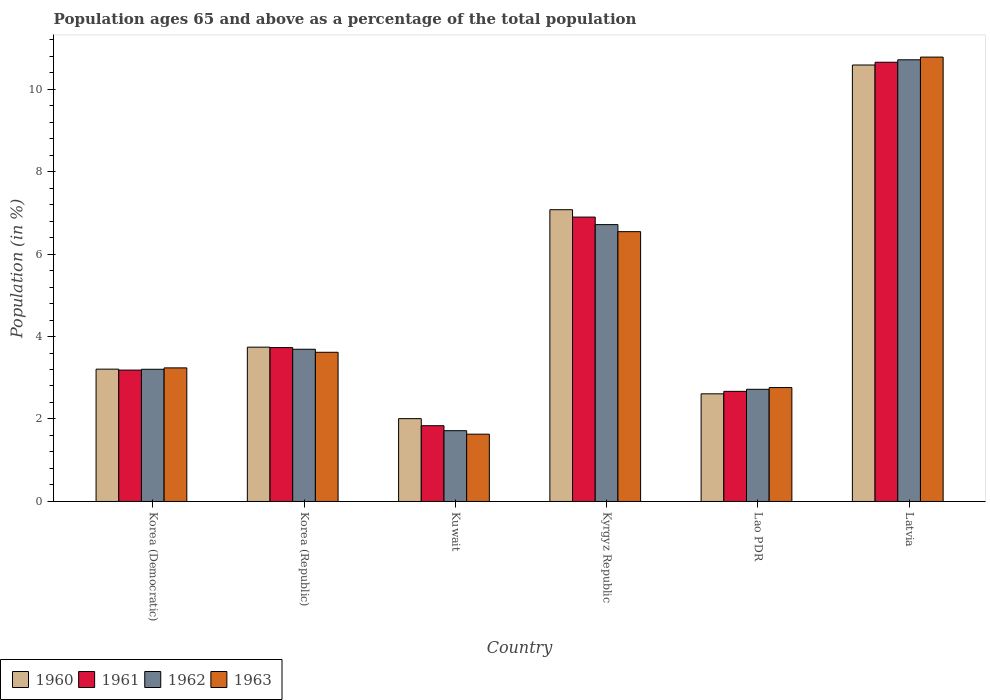How many different coloured bars are there?
Provide a short and direct response. 4. Are the number of bars per tick equal to the number of legend labels?
Offer a very short reply. Yes. How many bars are there on the 6th tick from the left?
Your answer should be compact. 4. How many bars are there on the 4th tick from the right?
Give a very brief answer. 4. In how many cases, is the number of bars for a given country not equal to the number of legend labels?
Keep it short and to the point. 0. What is the percentage of the population ages 65 and above in 1960 in Latvia?
Give a very brief answer. 10.58. Across all countries, what is the maximum percentage of the population ages 65 and above in 1960?
Give a very brief answer. 10.58. Across all countries, what is the minimum percentage of the population ages 65 and above in 1963?
Keep it short and to the point. 1.63. In which country was the percentage of the population ages 65 and above in 1962 maximum?
Provide a short and direct response. Latvia. In which country was the percentage of the population ages 65 and above in 1963 minimum?
Provide a succinct answer. Kuwait. What is the total percentage of the population ages 65 and above in 1962 in the graph?
Give a very brief answer. 28.75. What is the difference between the percentage of the population ages 65 and above in 1963 in Korea (Democratic) and that in Kyrgyz Republic?
Offer a very short reply. -3.3. What is the difference between the percentage of the population ages 65 and above in 1963 in Korea (Republic) and the percentage of the population ages 65 and above in 1961 in Lao PDR?
Provide a succinct answer. 0.95. What is the average percentage of the population ages 65 and above in 1960 per country?
Provide a succinct answer. 4.87. What is the difference between the percentage of the population ages 65 and above of/in 1963 and percentage of the population ages 65 and above of/in 1961 in Lao PDR?
Your answer should be compact. 0.09. What is the ratio of the percentage of the population ages 65 and above in 1960 in Korea (Democratic) to that in Lao PDR?
Provide a short and direct response. 1.23. Is the difference between the percentage of the population ages 65 and above in 1963 in Kyrgyz Republic and Latvia greater than the difference between the percentage of the population ages 65 and above in 1961 in Kyrgyz Republic and Latvia?
Provide a short and direct response. No. What is the difference between the highest and the second highest percentage of the population ages 65 and above in 1962?
Provide a short and direct response. 7.02. What is the difference between the highest and the lowest percentage of the population ages 65 and above in 1960?
Give a very brief answer. 8.57. In how many countries, is the percentage of the population ages 65 and above in 1961 greater than the average percentage of the population ages 65 and above in 1961 taken over all countries?
Your answer should be compact. 2. Is it the case that in every country, the sum of the percentage of the population ages 65 and above in 1961 and percentage of the population ages 65 and above in 1963 is greater than the sum of percentage of the population ages 65 and above in 1960 and percentage of the population ages 65 and above in 1962?
Offer a very short reply. No. How many bars are there?
Your response must be concise. 24. How many countries are there in the graph?
Your answer should be very brief. 6. What is the difference between two consecutive major ticks on the Y-axis?
Provide a short and direct response. 2. Are the values on the major ticks of Y-axis written in scientific E-notation?
Offer a very short reply. No. Does the graph contain grids?
Your answer should be compact. No. What is the title of the graph?
Make the answer very short. Population ages 65 and above as a percentage of the total population. Does "1963" appear as one of the legend labels in the graph?
Keep it short and to the point. Yes. What is the label or title of the X-axis?
Give a very brief answer. Country. What is the Population (in %) of 1960 in Korea (Democratic)?
Your answer should be very brief. 3.21. What is the Population (in %) of 1961 in Korea (Democratic)?
Ensure brevity in your answer.  3.19. What is the Population (in %) in 1962 in Korea (Democratic)?
Your answer should be compact. 3.21. What is the Population (in %) of 1963 in Korea (Democratic)?
Offer a terse response. 3.24. What is the Population (in %) of 1960 in Korea (Republic)?
Provide a short and direct response. 3.74. What is the Population (in %) of 1961 in Korea (Republic)?
Ensure brevity in your answer.  3.73. What is the Population (in %) in 1962 in Korea (Republic)?
Your answer should be very brief. 3.69. What is the Population (in %) of 1963 in Korea (Republic)?
Provide a succinct answer. 3.62. What is the Population (in %) of 1960 in Kuwait?
Make the answer very short. 2.01. What is the Population (in %) of 1961 in Kuwait?
Make the answer very short. 1.84. What is the Population (in %) in 1962 in Kuwait?
Give a very brief answer. 1.72. What is the Population (in %) in 1963 in Kuwait?
Keep it short and to the point. 1.63. What is the Population (in %) in 1960 in Kyrgyz Republic?
Provide a short and direct response. 7.07. What is the Population (in %) of 1961 in Kyrgyz Republic?
Give a very brief answer. 6.9. What is the Population (in %) of 1962 in Kyrgyz Republic?
Offer a very short reply. 6.71. What is the Population (in %) in 1963 in Kyrgyz Republic?
Your answer should be very brief. 6.54. What is the Population (in %) of 1960 in Lao PDR?
Provide a succinct answer. 2.61. What is the Population (in %) in 1961 in Lao PDR?
Keep it short and to the point. 2.67. What is the Population (in %) in 1962 in Lao PDR?
Provide a succinct answer. 2.72. What is the Population (in %) in 1963 in Lao PDR?
Keep it short and to the point. 2.76. What is the Population (in %) in 1960 in Latvia?
Provide a succinct answer. 10.58. What is the Population (in %) in 1961 in Latvia?
Provide a short and direct response. 10.65. What is the Population (in %) of 1962 in Latvia?
Provide a succinct answer. 10.71. What is the Population (in %) of 1963 in Latvia?
Offer a terse response. 10.77. Across all countries, what is the maximum Population (in %) in 1960?
Offer a very short reply. 10.58. Across all countries, what is the maximum Population (in %) in 1961?
Your response must be concise. 10.65. Across all countries, what is the maximum Population (in %) of 1962?
Provide a succinct answer. 10.71. Across all countries, what is the maximum Population (in %) of 1963?
Your answer should be very brief. 10.77. Across all countries, what is the minimum Population (in %) in 1960?
Make the answer very short. 2.01. Across all countries, what is the minimum Population (in %) in 1961?
Your response must be concise. 1.84. Across all countries, what is the minimum Population (in %) in 1962?
Offer a terse response. 1.72. Across all countries, what is the minimum Population (in %) of 1963?
Your answer should be very brief. 1.63. What is the total Population (in %) in 1960 in the graph?
Keep it short and to the point. 29.23. What is the total Population (in %) in 1961 in the graph?
Your answer should be very brief. 28.97. What is the total Population (in %) in 1962 in the graph?
Offer a terse response. 28.75. What is the total Population (in %) of 1963 in the graph?
Make the answer very short. 28.57. What is the difference between the Population (in %) of 1960 in Korea (Democratic) and that in Korea (Republic)?
Offer a terse response. -0.53. What is the difference between the Population (in %) in 1961 in Korea (Democratic) and that in Korea (Republic)?
Offer a terse response. -0.55. What is the difference between the Population (in %) of 1962 in Korea (Democratic) and that in Korea (Republic)?
Offer a very short reply. -0.49. What is the difference between the Population (in %) of 1963 in Korea (Democratic) and that in Korea (Republic)?
Offer a terse response. -0.38. What is the difference between the Population (in %) in 1960 in Korea (Democratic) and that in Kuwait?
Provide a short and direct response. 1.2. What is the difference between the Population (in %) in 1961 in Korea (Democratic) and that in Kuwait?
Provide a succinct answer. 1.35. What is the difference between the Population (in %) in 1962 in Korea (Democratic) and that in Kuwait?
Ensure brevity in your answer.  1.49. What is the difference between the Population (in %) in 1963 in Korea (Democratic) and that in Kuwait?
Offer a terse response. 1.61. What is the difference between the Population (in %) in 1960 in Korea (Democratic) and that in Kyrgyz Republic?
Your answer should be very brief. -3.87. What is the difference between the Population (in %) of 1961 in Korea (Democratic) and that in Kyrgyz Republic?
Ensure brevity in your answer.  -3.71. What is the difference between the Population (in %) in 1962 in Korea (Democratic) and that in Kyrgyz Republic?
Keep it short and to the point. -3.51. What is the difference between the Population (in %) in 1963 in Korea (Democratic) and that in Kyrgyz Republic?
Provide a short and direct response. -3.3. What is the difference between the Population (in %) in 1960 in Korea (Democratic) and that in Lao PDR?
Offer a very short reply. 0.6. What is the difference between the Population (in %) in 1961 in Korea (Democratic) and that in Lao PDR?
Your answer should be very brief. 0.52. What is the difference between the Population (in %) of 1962 in Korea (Democratic) and that in Lao PDR?
Your answer should be very brief. 0.49. What is the difference between the Population (in %) in 1963 in Korea (Democratic) and that in Lao PDR?
Make the answer very short. 0.48. What is the difference between the Population (in %) of 1960 in Korea (Democratic) and that in Latvia?
Give a very brief answer. -7.37. What is the difference between the Population (in %) in 1961 in Korea (Democratic) and that in Latvia?
Keep it short and to the point. -7.46. What is the difference between the Population (in %) of 1962 in Korea (Democratic) and that in Latvia?
Your response must be concise. -7.5. What is the difference between the Population (in %) in 1963 in Korea (Democratic) and that in Latvia?
Your answer should be very brief. -7.54. What is the difference between the Population (in %) of 1960 in Korea (Republic) and that in Kuwait?
Give a very brief answer. 1.73. What is the difference between the Population (in %) in 1961 in Korea (Republic) and that in Kuwait?
Offer a terse response. 1.89. What is the difference between the Population (in %) of 1962 in Korea (Republic) and that in Kuwait?
Provide a succinct answer. 1.97. What is the difference between the Population (in %) of 1963 in Korea (Republic) and that in Kuwait?
Your response must be concise. 1.99. What is the difference between the Population (in %) of 1960 in Korea (Republic) and that in Kyrgyz Republic?
Offer a very short reply. -3.33. What is the difference between the Population (in %) in 1961 in Korea (Republic) and that in Kyrgyz Republic?
Provide a short and direct response. -3.16. What is the difference between the Population (in %) in 1962 in Korea (Republic) and that in Kyrgyz Republic?
Your response must be concise. -3.02. What is the difference between the Population (in %) in 1963 in Korea (Republic) and that in Kyrgyz Republic?
Your answer should be very brief. -2.93. What is the difference between the Population (in %) of 1960 in Korea (Republic) and that in Lao PDR?
Ensure brevity in your answer.  1.13. What is the difference between the Population (in %) of 1961 in Korea (Republic) and that in Lao PDR?
Provide a short and direct response. 1.06. What is the difference between the Population (in %) in 1962 in Korea (Republic) and that in Lao PDR?
Make the answer very short. 0.97. What is the difference between the Population (in %) in 1963 in Korea (Republic) and that in Lao PDR?
Your answer should be very brief. 0.86. What is the difference between the Population (in %) of 1960 in Korea (Republic) and that in Latvia?
Offer a terse response. -6.84. What is the difference between the Population (in %) of 1961 in Korea (Republic) and that in Latvia?
Keep it short and to the point. -6.92. What is the difference between the Population (in %) of 1962 in Korea (Republic) and that in Latvia?
Your response must be concise. -7.02. What is the difference between the Population (in %) of 1963 in Korea (Republic) and that in Latvia?
Your answer should be very brief. -7.16. What is the difference between the Population (in %) in 1960 in Kuwait and that in Kyrgyz Republic?
Your answer should be compact. -5.07. What is the difference between the Population (in %) in 1961 in Kuwait and that in Kyrgyz Republic?
Make the answer very short. -5.06. What is the difference between the Population (in %) in 1962 in Kuwait and that in Kyrgyz Republic?
Give a very brief answer. -5. What is the difference between the Population (in %) in 1963 in Kuwait and that in Kyrgyz Republic?
Keep it short and to the point. -4.91. What is the difference between the Population (in %) of 1960 in Kuwait and that in Lao PDR?
Give a very brief answer. -0.6. What is the difference between the Population (in %) in 1961 in Kuwait and that in Lao PDR?
Ensure brevity in your answer.  -0.83. What is the difference between the Population (in %) of 1962 in Kuwait and that in Lao PDR?
Your response must be concise. -1. What is the difference between the Population (in %) in 1963 in Kuwait and that in Lao PDR?
Offer a very short reply. -1.13. What is the difference between the Population (in %) in 1960 in Kuwait and that in Latvia?
Your response must be concise. -8.57. What is the difference between the Population (in %) in 1961 in Kuwait and that in Latvia?
Provide a short and direct response. -8.81. What is the difference between the Population (in %) of 1962 in Kuwait and that in Latvia?
Provide a short and direct response. -8.99. What is the difference between the Population (in %) in 1963 in Kuwait and that in Latvia?
Your answer should be very brief. -9.14. What is the difference between the Population (in %) in 1960 in Kyrgyz Republic and that in Lao PDR?
Your answer should be compact. 4.46. What is the difference between the Population (in %) in 1961 in Kyrgyz Republic and that in Lao PDR?
Provide a short and direct response. 4.22. What is the difference between the Population (in %) in 1962 in Kyrgyz Republic and that in Lao PDR?
Your answer should be very brief. 3.99. What is the difference between the Population (in %) of 1963 in Kyrgyz Republic and that in Lao PDR?
Provide a short and direct response. 3.78. What is the difference between the Population (in %) in 1960 in Kyrgyz Republic and that in Latvia?
Your response must be concise. -3.51. What is the difference between the Population (in %) in 1961 in Kyrgyz Republic and that in Latvia?
Give a very brief answer. -3.75. What is the difference between the Population (in %) in 1962 in Kyrgyz Republic and that in Latvia?
Your answer should be compact. -4. What is the difference between the Population (in %) of 1963 in Kyrgyz Republic and that in Latvia?
Ensure brevity in your answer.  -4.23. What is the difference between the Population (in %) of 1960 in Lao PDR and that in Latvia?
Offer a very short reply. -7.97. What is the difference between the Population (in %) of 1961 in Lao PDR and that in Latvia?
Offer a very short reply. -7.98. What is the difference between the Population (in %) in 1962 in Lao PDR and that in Latvia?
Give a very brief answer. -7.99. What is the difference between the Population (in %) of 1963 in Lao PDR and that in Latvia?
Your response must be concise. -8.01. What is the difference between the Population (in %) in 1960 in Korea (Democratic) and the Population (in %) in 1961 in Korea (Republic)?
Your response must be concise. -0.52. What is the difference between the Population (in %) of 1960 in Korea (Democratic) and the Population (in %) of 1962 in Korea (Republic)?
Ensure brevity in your answer.  -0.48. What is the difference between the Population (in %) of 1960 in Korea (Democratic) and the Population (in %) of 1963 in Korea (Republic)?
Make the answer very short. -0.41. What is the difference between the Population (in %) in 1961 in Korea (Democratic) and the Population (in %) in 1962 in Korea (Republic)?
Ensure brevity in your answer.  -0.51. What is the difference between the Population (in %) in 1961 in Korea (Democratic) and the Population (in %) in 1963 in Korea (Republic)?
Your answer should be compact. -0.43. What is the difference between the Population (in %) in 1962 in Korea (Democratic) and the Population (in %) in 1963 in Korea (Republic)?
Provide a succinct answer. -0.41. What is the difference between the Population (in %) of 1960 in Korea (Democratic) and the Population (in %) of 1961 in Kuwait?
Provide a succinct answer. 1.37. What is the difference between the Population (in %) of 1960 in Korea (Democratic) and the Population (in %) of 1962 in Kuwait?
Give a very brief answer. 1.49. What is the difference between the Population (in %) in 1960 in Korea (Democratic) and the Population (in %) in 1963 in Kuwait?
Keep it short and to the point. 1.58. What is the difference between the Population (in %) of 1961 in Korea (Democratic) and the Population (in %) of 1962 in Kuwait?
Give a very brief answer. 1.47. What is the difference between the Population (in %) in 1961 in Korea (Democratic) and the Population (in %) in 1963 in Kuwait?
Provide a succinct answer. 1.55. What is the difference between the Population (in %) in 1962 in Korea (Democratic) and the Population (in %) in 1963 in Kuwait?
Your response must be concise. 1.57. What is the difference between the Population (in %) in 1960 in Korea (Democratic) and the Population (in %) in 1961 in Kyrgyz Republic?
Offer a terse response. -3.69. What is the difference between the Population (in %) in 1960 in Korea (Democratic) and the Population (in %) in 1962 in Kyrgyz Republic?
Offer a terse response. -3.5. What is the difference between the Population (in %) in 1960 in Korea (Democratic) and the Population (in %) in 1963 in Kyrgyz Republic?
Your response must be concise. -3.33. What is the difference between the Population (in %) in 1961 in Korea (Democratic) and the Population (in %) in 1962 in Kyrgyz Republic?
Make the answer very short. -3.53. What is the difference between the Population (in %) of 1961 in Korea (Democratic) and the Population (in %) of 1963 in Kyrgyz Republic?
Your answer should be compact. -3.36. What is the difference between the Population (in %) in 1962 in Korea (Democratic) and the Population (in %) in 1963 in Kyrgyz Republic?
Keep it short and to the point. -3.34. What is the difference between the Population (in %) in 1960 in Korea (Democratic) and the Population (in %) in 1961 in Lao PDR?
Provide a succinct answer. 0.54. What is the difference between the Population (in %) in 1960 in Korea (Democratic) and the Population (in %) in 1962 in Lao PDR?
Keep it short and to the point. 0.49. What is the difference between the Population (in %) of 1960 in Korea (Democratic) and the Population (in %) of 1963 in Lao PDR?
Give a very brief answer. 0.45. What is the difference between the Population (in %) in 1961 in Korea (Democratic) and the Population (in %) in 1962 in Lao PDR?
Your answer should be compact. 0.47. What is the difference between the Population (in %) of 1961 in Korea (Democratic) and the Population (in %) of 1963 in Lao PDR?
Your response must be concise. 0.42. What is the difference between the Population (in %) of 1962 in Korea (Democratic) and the Population (in %) of 1963 in Lao PDR?
Provide a short and direct response. 0.44. What is the difference between the Population (in %) in 1960 in Korea (Democratic) and the Population (in %) in 1961 in Latvia?
Provide a succinct answer. -7.44. What is the difference between the Population (in %) of 1960 in Korea (Democratic) and the Population (in %) of 1962 in Latvia?
Offer a terse response. -7.5. What is the difference between the Population (in %) in 1960 in Korea (Democratic) and the Population (in %) in 1963 in Latvia?
Provide a succinct answer. -7.57. What is the difference between the Population (in %) of 1961 in Korea (Democratic) and the Population (in %) of 1962 in Latvia?
Provide a short and direct response. -7.52. What is the difference between the Population (in %) of 1961 in Korea (Democratic) and the Population (in %) of 1963 in Latvia?
Keep it short and to the point. -7.59. What is the difference between the Population (in %) of 1962 in Korea (Democratic) and the Population (in %) of 1963 in Latvia?
Provide a succinct answer. -7.57. What is the difference between the Population (in %) of 1960 in Korea (Republic) and the Population (in %) of 1961 in Kuwait?
Ensure brevity in your answer.  1.9. What is the difference between the Population (in %) of 1960 in Korea (Republic) and the Population (in %) of 1962 in Kuwait?
Your answer should be very brief. 2.03. What is the difference between the Population (in %) in 1960 in Korea (Republic) and the Population (in %) in 1963 in Kuwait?
Ensure brevity in your answer.  2.11. What is the difference between the Population (in %) of 1961 in Korea (Republic) and the Population (in %) of 1962 in Kuwait?
Offer a terse response. 2.02. What is the difference between the Population (in %) in 1961 in Korea (Republic) and the Population (in %) in 1963 in Kuwait?
Offer a terse response. 2.1. What is the difference between the Population (in %) in 1962 in Korea (Republic) and the Population (in %) in 1963 in Kuwait?
Make the answer very short. 2.06. What is the difference between the Population (in %) in 1960 in Korea (Republic) and the Population (in %) in 1961 in Kyrgyz Republic?
Your answer should be compact. -3.15. What is the difference between the Population (in %) in 1960 in Korea (Republic) and the Population (in %) in 1962 in Kyrgyz Republic?
Provide a succinct answer. -2.97. What is the difference between the Population (in %) of 1960 in Korea (Republic) and the Population (in %) of 1963 in Kyrgyz Republic?
Keep it short and to the point. -2.8. What is the difference between the Population (in %) of 1961 in Korea (Republic) and the Population (in %) of 1962 in Kyrgyz Republic?
Keep it short and to the point. -2.98. What is the difference between the Population (in %) in 1961 in Korea (Republic) and the Population (in %) in 1963 in Kyrgyz Republic?
Ensure brevity in your answer.  -2.81. What is the difference between the Population (in %) in 1962 in Korea (Republic) and the Population (in %) in 1963 in Kyrgyz Republic?
Give a very brief answer. -2.85. What is the difference between the Population (in %) of 1960 in Korea (Republic) and the Population (in %) of 1961 in Lao PDR?
Keep it short and to the point. 1.07. What is the difference between the Population (in %) in 1960 in Korea (Republic) and the Population (in %) in 1962 in Lao PDR?
Your answer should be very brief. 1.02. What is the difference between the Population (in %) of 1960 in Korea (Republic) and the Population (in %) of 1963 in Lao PDR?
Provide a succinct answer. 0.98. What is the difference between the Population (in %) of 1961 in Korea (Republic) and the Population (in %) of 1962 in Lao PDR?
Your response must be concise. 1.01. What is the difference between the Population (in %) of 1961 in Korea (Republic) and the Population (in %) of 1963 in Lao PDR?
Your answer should be compact. 0.97. What is the difference between the Population (in %) of 1962 in Korea (Republic) and the Population (in %) of 1963 in Lao PDR?
Offer a very short reply. 0.93. What is the difference between the Population (in %) of 1960 in Korea (Republic) and the Population (in %) of 1961 in Latvia?
Provide a short and direct response. -6.91. What is the difference between the Population (in %) of 1960 in Korea (Republic) and the Population (in %) of 1962 in Latvia?
Your answer should be compact. -6.97. What is the difference between the Population (in %) in 1960 in Korea (Republic) and the Population (in %) in 1963 in Latvia?
Make the answer very short. -7.03. What is the difference between the Population (in %) in 1961 in Korea (Republic) and the Population (in %) in 1962 in Latvia?
Your answer should be compact. -6.98. What is the difference between the Population (in %) of 1961 in Korea (Republic) and the Population (in %) of 1963 in Latvia?
Provide a succinct answer. -7.04. What is the difference between the Population (in %) of 1962 in Korea (Republic) and the Population (in %) of 1963 in Latvia?
Your response must be concise. -7.08. What is the difference between the Population (in %) in 1960 in Kuwait and the Population (in %) in 1961 in Kyrgyz Republic?
Offer a very short reply. -4.89. What is the difference between the Population (in %) of 1960 in Kuwait and the Population (in %) of 1962 in Kyrgyz Republic?
Your response must be concise. -4.7. What is the difference between the Population (in %) in 1960 in Kuwait and the Population (in %) in 1963 in Kyrgyz Republic?
Your answer should be compact. -4.53. What is the difference between the Population (in %) of 1961 in Kuwait and the Population (in %) of 1962 in Kyrgyz Republic?
Your answer should be very brief. -4.88. What is the difference between the Population (in %) of 1961 in Kuwait and the Population (in %) of 1963 in Kyrgyz Republic?
Provide a short and direct response. -4.71. What is the difference between the Population (in %) of 1962 in Kuwait and the Population (in %) of 1963 in Kyrgyz Republic?
Keep it short and to the point. -4.83. What is the difference between the Population (in %) in 1960 in Kuwait and the Population (in %) in 1961 in Lao PDR?
Provide a short and direct response. -0.66. What is the difference between the Population (in %) in 1960 in Kuwait and the Population (in %) in 1962 in Lao PDR?
Offer a terse response. -0.71. What is the difference between the Population (in %) of 1960 in Kuwait and the Population (in %) of 1963 in Lao PDR?
Provide a succinct answer. -0.75. What is the difference between the Population (in %) in 1961 in Kuwait and the Population (in %) in 1962 in Lao PDR?
Keep it short and to the point. -0.88. What is the difference between the Population (in %) of 1961 in Kuwait and the Population (in %) of 1963 in Lao PDR?
Your answer should be very brief. -0.92. What is the difference between the Population (in %) in 1962 in Kuwait and the Population (in %) in 1963 in Lao PDR?
Keep it short and to the point. -1.05. What is the difference between the Population (in %) of 1960 in Kuwait and the Population (in %) of 1961 in Latvia?
Give a very brief answer. -8.64. What is the difference between the Population (in %) of 1960 in Kuwait and the Population (in %) of 1962 in Latvia?
Offer a very short reply. -8.7. What is the difference between the Population (in %) in 1960 in Kuwait and the Population (in %) in 1963 in Latvia?
Provide a succinct answer. -8.77. What is the difference between the Population (in %) in 1961 in Kuwait and the Population (in %) in 1962 in Latvia?
Provide a short and direct response. -8.87. What is the difference between the Population (in %) in 1961 in Kuwait and the Population (in %) in 1963 in Latvia?
Your response must be concise. -8.94. What is the difference between the Population (in %) in 1962 in Kuwait and the Population (in %) in 1963 in Latvia?
Provide a short and direct response. -9.06. What is the difference between the Population (in %) in 1960 in Kyrgyz Republic and the Population (in %) in 1961 in Lao PDR?
Provide a short and direct response. 4.4. What is the difference between the Population (in %) in 1960 in Kyrgyz Republic and the Population (in %) in 1962 in Lao PDR?
Provide a short and direct response. 4.35. What is the difference between the Population (in %) of 1960 in Kyrgyz Republic and the Population (in %) of 1963 in Lao PDR?
Provide a short and direct response. 4.31. What is the difference between the Population (in %) of 1961 in Kyrgyz Republic and the Population (in %) of 1962 in Lao PDR?
Make the answer very short. 4.18. What is the difference between the Population (in %) in 1961 in Kyrgyz Republic and the Population (in %) in 1963 in Lao PDR?
Provide a short and direct response. 4.13. What is the difference between the Population (in %) in 1962 in Kyrgyz Republic and the Population (in %) in 1963 in Lao PDR?
Offer a terse response. 3.95. What is the difference between the Population (in %) of 1960 in Kyrgyz Republic and the Population (in %) of 1961 in Latvia?
Ensure brevity in your answer.  -3.58. What is the difference between the Population (in %) in 1960 in Kyrgyz Republic and the Population (in %) in 1962 in Latvia?
Offer a terse response. -3.63. What is the difference between the Population (in %) of 1960 in Kyrgyz Republic and the Population (in %) of 1963 in Latvia?
Provide a succinct answer. -3.7. What is the difference between the Population (in %) of 1961 in Kyrgyz Republic and the Population (in %) of 1962 in Latvia?
Make the answer very short. -3.81. What is the difference between the Population (in %) in 1961 in Kyrgyz Republic and the Population (in %) in 1963 in Latvia?
Offer a very short reply. -3.88. What is the difference between the Population (in %) in 1962 in Kyrgyz Republic and the Population (in %) in 1963 in Latvia?
Keep it short and to the point. -4.06. What is the difference between the Population (in %) of 1960 in Lao PDR and the Population (in %) of 1961 in Latvia?
Give a very brief answer. -8.04. What is the difference between the Population (in %) in 1960 in Lao PDR and the Population (in %) in 1962 in Latvia?
Your response must be concise. -8.1. What is the difference between the Population (in %) in 1960 in Lao PDR and the Population (in %) in 1963 in Latvia?
Ensure brevity in your answer.  -8.16. What is the difference between the Population (in %) in 1961 in Lao PDR and the Population (in %) in 1962 in Latvia?
Your response must be concise. -8.04. What is the difference between the Population (in %) in 1961 in Lao PDR and the Population (in %) in 1963 in Latvia?
Give a very brief answer. -8.1. What is the difference between the Population (in %) of 1962 in Lao PDR and the Population (in %) of 1963 in Latvia?
Your answer should be very brief. -8.05. What is the average Population (in %) in 1960 per country?
Offer a terse response. 4.87. What is the average Population (in %) in 1961 per country?
Your answer should be compact. 4.83. What is the average Population (in %) of 1962 per country?
Your answer should be compact. 4.79. What is the average Population (in %) of 1963 per country?
Provide a succinct answer. 4.76. What is the difference between the Population (in %) of 1960 and Population (in %) of 1961 in Korea (Democratic)?
Provide a succinct answer. 0.02. What is the difference between the Population (in %) of 1960 and Population (in %) of 1962 in Korea (Democratic)?
Your response must be concise. 0. What is the difference between the Population (in %) in 1960 and Population (in %) in 1963 in Korea (Democratic)?
Provide a succinct answer. -0.03. What is the difference between the Population (in %) in 1961 and Population (in %) in 1962 in Korea (Democratic)?
Provide a succinct answer. -0.02. What is the difference between the Population (in %) in 1961 and Population (in %) in 1963 in Korea (Democratic)?
Keep it short and to the point. -0.05. What is the difference between the Population (in %) of 1962 and Population (in %) of 1963 in Korea (Democratic)?
Your answer should be compact. -0.03. What is the difference between the Population (in %) in 1960 and Population (in %) in 1961 in Korea (Republic)?
Offer a very short reply. 0.01. What is the difference between the Population (in %) of 1960 and Population (in %) of 1962 in Korea (Republic)?
Provide a short and direct response. 0.05. What is the difference between the Population (in %) of 1960 and Population (in %) of 1963 in Korea (Republic)?
Your answer should be very brief. 0.12. What is the difference between the Population (in %) in 1961 and Population (in %) in 1962 in Korea (Republic)?
Offer a very short reply. 0.04. What is the difference between the Population (in %) of 1961 and Population (in %) of 1963 in Korea (Republic)?
Your answer should be compact. 0.11. What is the difference between the Population (in %) in 1962 and Population (in %) in 1963 in Korea (Republic)?
Offer a terse response. 0.07. What is the difference between the Population (in %) in 1960 and Population (in %) in 1961 in Kuwait?
Ensure brevity in your answer.  0.17. What is the difference between the Population (in %) in 1960 and Population (in %) in 1962 in Kuwait?
Offer a terse response. 0.29. What is the difference between the Population (in %) of 1960 and Population (in %) of 1963 in Kuwait?
Ensure brevity in your answer.  0.38. What is the difference between the Population (in %) of 1961 and Population (in %) of 1962 in Kuwait?
Give a very brief answer. 0.12. What is the difference between the Population (in %) of 1961 and Population (in %) of 1963 in Kuwait?
Keep it short and to the point. 0.21. What is the difference between the Population (in %) of 1962 and Population (in %) of 1963 in Kuwait?
Your answer should be compact. 0.08. What is the difference between the Population (in %) in 1960 and Population (in %) in 1961 in Kyrgyz Republic?
Your answer should be compact. 0.18. What is the difference between the Population (in %) of 1960 and Population (in %) of 1962 in Kyrgyz Republic?
Provide a short and direct response. 0.36. What is the difference between the Population (in %) in 1960 and Population (in %) in 1963 in Kyrgyz Republic?
Your answer should be very brief. 0.53. What is the difference between the Population (in %) of 1961 and Population (in %) of 1962 in Kyrgyz Republic?
Provide a succinct answer. 0.18. What is the difference between the Population (in %) of 1961 and Population (in %) of 1963 in Kyrgyz Republic?
Offer a terse response. 0.35. What is the difference between the Population (in %) of 1962 and Population (in %) of 1963 in Kyrgyz Republic?
Keep it short and to the point. 0.17. What is the difference between the Population (in %) of 1960 and Population (in %) of 1961 in Lao PDR?
Provide a short and direct response. -0.06. What is the difference between the Population (in %) of 1960 and Population (in %) of 1962 in Lao PDR?
Your answer should be compact. -0.11. What is the difference between the Population (in %) in 1960 and Population (in %) in 1963 in Lao PDR?
Offer a terse response. -0.15. What is the difference between the Population (in %) of 1961 and Population (in %) of 1962 in Lao PDR?
Offer a terse response. -0.05. What is the difference between the Population (in %) in 1961 and Population (in %) in 1963 in Lao PDR?
Provide a succinct answer. -0.09. What is the difference between the Population (in %) in 1962 and Population (in %) in 1963 in Lao PDR?
Keep it short and to the point. -0.04. What is the difference between the Population (in %) in 1960 and Population (in %) in 1961 in Latvia?
Offer a very short reply. -0.07. What is the difference between the Population (in %) of 1960 and Population (in %) of 1962 in Latvia?
Provide a short and direct response. -0.13. What is the difference between the Population (in %) in 1960 and Population (in %) in 1963 in Latvia?
Your response must be concise. -0.19. What is the difference between the Population (in %) in 1961 and Population (in %) in 1962 in Latvia?
Ensure brevity in your answer.  -0.06. What is the difference between the Population (in %) in 1961 and Population (in %) in 1963 in Latvia?
Give a very brief answer. -0.12. What is the difference between the Population (in %) of 1962 and Population (in %) of 1963 in Latvia?
Your answer should be very brief. -0.07. What is the ratio of the Population (in %) of 1960 in Korea (Democratic) to that in Korea (Republic)?
Your answer should be compact. 0.86. What is the ratio of the Population (in %) of 1961 in Korea (Democratic) to that in Korea (Republic)?
Your answer should be very brief. 0.85. What is the ratio of the Population (in %) in 1962 in Korea (Democratic) to that in Korea (Republic)?
Keep it short and to the point. 0.87. What is the ratio of the Population (in %) of 1963 in Korea (Democratic) to that in Korea (Republic)?
Your answer should be very brief. 0.9. What is the ratio of the Population (in %) in 1960 in Korea (Democratic) to that in Kuwait?
Give a very brief answer. 1.6. What is the ratio of the Population (in %) in 1961 in Korea (Democratic) to that in Kuwait?
Provide a short and direct response. 1.73. What is the ratio of the Population (in %) of 1962 in Korea (Democratic) to that in Kuwait?
Offer a terse response. 1.87. What is the ratio of the Population (in %) in 1963 in Korea (Democratic) to that in Kuwait?
Provide a succinct answer. 1.99. What is the ratio of the Population (in %) in 1960 in Korea (Democratic) to that in Kyrgyz Republic?
Provide a succinct answer. 0.45. What is the ratio of the Population (in %) of 1961 in Korea (Democratic) to that in Kyrgyz Republic?
Ensure brevity in your answer.  0.46. What is the ratio of the Population (in %) in 1962 in Korea (Democratic) to that in Kyrgyz Republic?
Keep it short and to the point. 0.48. What is the ratio of the Population (in %) in 1963 in Korea (Democratic) to that in Kyrgyz Republic?
Your answer should be compact. 0.5. What is the ratio of the Population (in %) in 1960 in Korea (Democratic) to that in Lao PDR?
Provide a succinct answer. 1.23. What is the ratio of the Population (in %) in 1961 in Korea (Democratic) to that in Lao PDR?
Make the answer very short. 1.19. What is the ratio of the Population (in %) of 1962 in Korea (Democratic) to that in Lao PDR?
Your answer should be very brief. 1.18. What is the ratio of the Population (in %) of 1963 in Korea (Democratic) to that in Lao PDR?
Provide a succinct answer. 1.17. What is the ratio of the Population (in %) in 1960 in Korea (Democratic) to that in Latvia?
Keep it short and to the point. 0.3. What is the ratio of the Population (in %) of 1961 in Korea (Democratic) to that in Latvia?
Offer a terse response. 0.3. What is the ratio of the Population (in %) in 1962 in Korea (Democratic) to that in Latvia?
Offer a terse response. 0.3. What is the ratio of the Population (in %) of 1963 in Korea (Democratic) to that in Latvia?
Your answer should be very brief. 0.3. What is the ratio of the Population (in %) in 1960 in Korea (Republic) to that in Kuwait?
Offer a terse response. 1.86. What is the ratio of the Population (in %) of 1961 in Korea (Republic) to that in Kuwait?
Your response must be concise. 2.03. What is the ratio of the Population (in %) of 1962 in Korea (Republic) to that in Kuwait?
Give a very brief answer. 2.15. What is the ratio of the Population (in %) in 1963 in Korea (Republic) to that in Kuwait?
Provide a short and direct response. 2.22. What is the ratio of the Population (in %) of 1960 in Korea (Republic) to that in Kyrgyz Republic?
Make the answer very short. 0.53. What is the ratio of the Population (in %) of 1961 in Korea (Republic) to that in Kyrgyz Republic?
Your answer should be compact. 0.54. What is the ratio of the Population (in %) in 1962 in Korea (Republic) to that in Kyrgyz Republic?
Your answer should be very brief. 0.55. What is the ratio of the Population (in %) in 1963 in Korea (Republic) to that in Kyrgyz Republic?
Keep it short and to the point. 0.55. What is the ratio of the Population (in %) in 1960 in Korea (Republic) to that in Lao PDR?
Provide a short and direct response. 1.43. What is the ratio of the Population (in %) in 1961 in Korea (Republic) to that in Lao PDR?
Your answer should be very brief. 1.4. What is the ratio of the Population (in %) of 1962 in Korea (Republic) to that in Lao PDR?
Your answer should be very brief. 1.36. What is the ratio of the Population (in %) of 1963 in Korea (Republic) to that in Lao PDR?
Offer a very short reply. 1.31. What is the ratio of the Population (in %) in 1960 in Korea (Republic) to that in Latvia?
Your answer should be very brief. 0.35. What is the ratio of the Population (in %) of 1961 in Korea (Republic) to that in Latvia?
Make the answer very short. 0.35. What is the ratio of the Population (in %) in 1962 in Korea (Republic) to that in Latvia?
Offer a very short reply. 0.34. What is the ratio of the Population (in %) in 1963 in Korea (Republic) to that in Latvia?
Keep it short and to the point. 0.34. What is the ratio of the Population (in %) in 1960 in Kuwait to that in Kyrgyz Republic?
Offer a terse response. 0.28. What is the ratio of the Population (in %) of 1961 in Kuwait to that in Kyrgyz Republic?
Ensure brevity in your answer.  0.27. What is the ratio of the Population (in %) of 1962 in Kuwait to that in Kyrgyz Republic?
Your answer should be compact. 0.26. What is the ratio of the Population (in %) of 1963 in Kuwait to that in Kyrgyz Republic?
Your answer should be compact. 0.25. What is the ratio of the Population (in %) of 1960 in Kuwait to that in Lao PDR?
Provide a short and direct response. 0.77. What is the ratio of the Population (in %) of 1961 in Kuwait to that in Lao PDR?
Make the answer very short. 0.69. What is the ratio of the Population (in %) in 1962 in Kuwait to that in Lao PDR?
Your answer should be compact. 0.63. What is the ratio of the Population (in %) of 1963 in Kuwait to that in Lao PDR?
Your response must be concise. 0.59. What is the ratio of the Population (in %) in 1960 in Kuwait to that in Latvia?
Keep it short and to the point. 0.19. What is the ratio of the Population (in %) of 1961 in Kuwait to that in Latvia?
Offer a very short reply. 0.17. What is the ratio of the Population (in %) of 1962 in Kuwait to that in Latvia?
Offer a very short reply. 0.16. What is the ratio of the Population (in %) in 1963 in Kuwait to that in Latvia?
Provide a short and direct response. 0.15. What is the ratio of the Population (in %) of 1960 in Kyrgyz Republic to that in Lao PDR?
Your answer should be compact. 2.71. What is the ratio of the Population (in %) of 1961 in Kyrgyz Republic to that in Lao PDR?
Provide a short and direct response. 2.58. What is the ratio of the Population (in %) in 1962 in Kyrgyz Republic to that in Lao PDR?
Keep it short and to the point. 2.47. What is the ratio of the Population (in %) in 1963 in Kyrgyz Republic to that in Lao PDR?
Offer a very short reply. 2.37. What is the ratio of the Population (in %) in 1960 in Kyrgyz Republic to that in Latvia?
Your answer should be very brief. 0.67. What is the ratio of the Population (in %) in 1961 in Kyrgyz Republic to that in Latvia?
Make the answer very short. 0.65. What is the ratio of the Population (in %) in 1962 in Kyrgyz Republic to that in Latvia?
Your answer should be very brief. 0.63. What is the ratio of the Population (in %) in 1963 in Kyrgyz Republic to that in Latvia?
Ensure brevity in your answer.  0.61. What is the ratio of the Population (in %) of 1960 in Lao PDR to that in Latvia?
Ensure brevity in your answer.  0.25. What is the ratio of the Population (in %) of 1961 in Lao PDR to that in Latvia?
Offer a very short reply. 0.25. What is the ratio of the Population (in %) in 1962 in Lao PDR to that in Latvia?
Keep it short and to the point. 0.25. What is the ratio of the Population (in %) in 1963 in Lao PDR to that in Latvia?
Your answer should be compact. 0.26. What is the difference between the highest and the second highest Population (in %) in 1960?
Your response must be concise. 3.51. What is the difference between the highest and the second highest Population (in %) of 1961?
Provide a succinct answer. 3.75. What is the difference between the highest and the second highest Population (in %) in 1962?
Make the answer very short. 4. What is the difference between the highest and the second highest Population (in %) of 1963?
Offer a terse response. 4.23. What is the difference between the highest and the lowest Population (in %) in 1960?
Make the answer very short. 8.57. What is the difference between the highest and the lowest Population (in %) in 1961?
Ensure brevity in your answer.  8.81. What is the difference between the highest and the lowest Population (in %) in 1962?
Make the answer very short. 8.99. What is the difference between the highest and the lowest Population (in %) in 1963?
Make the answer very short. 9.14. 